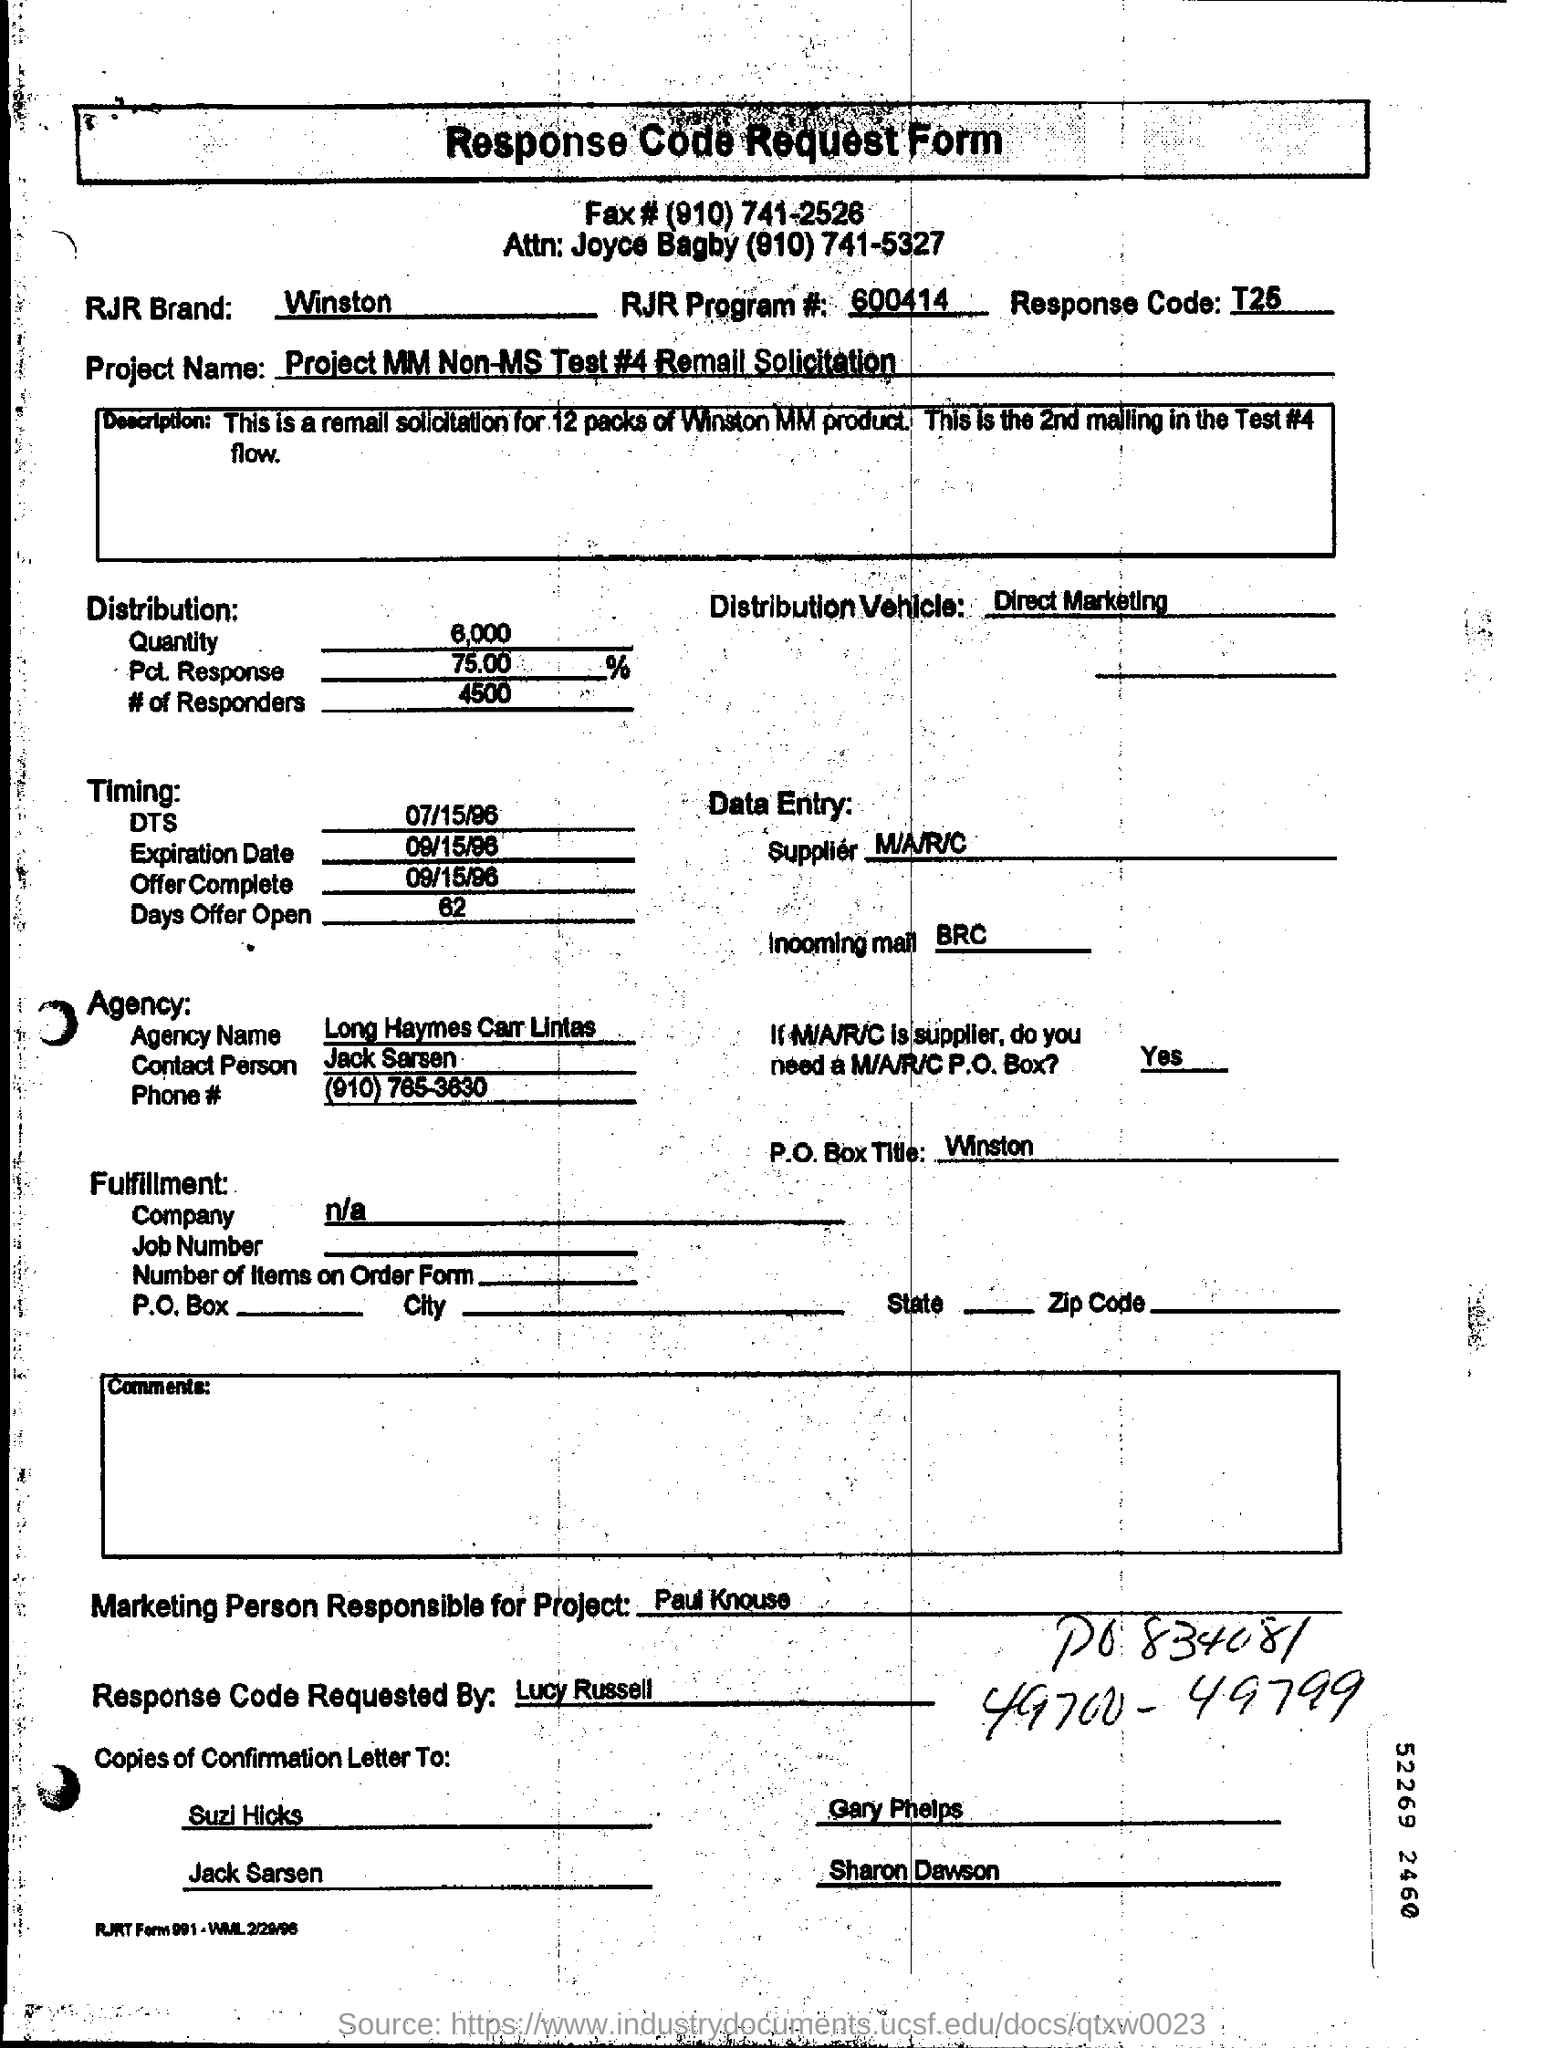Draw attention to some important aspects in this diagram. The RJR Program# mentioned in the form is 600414. 